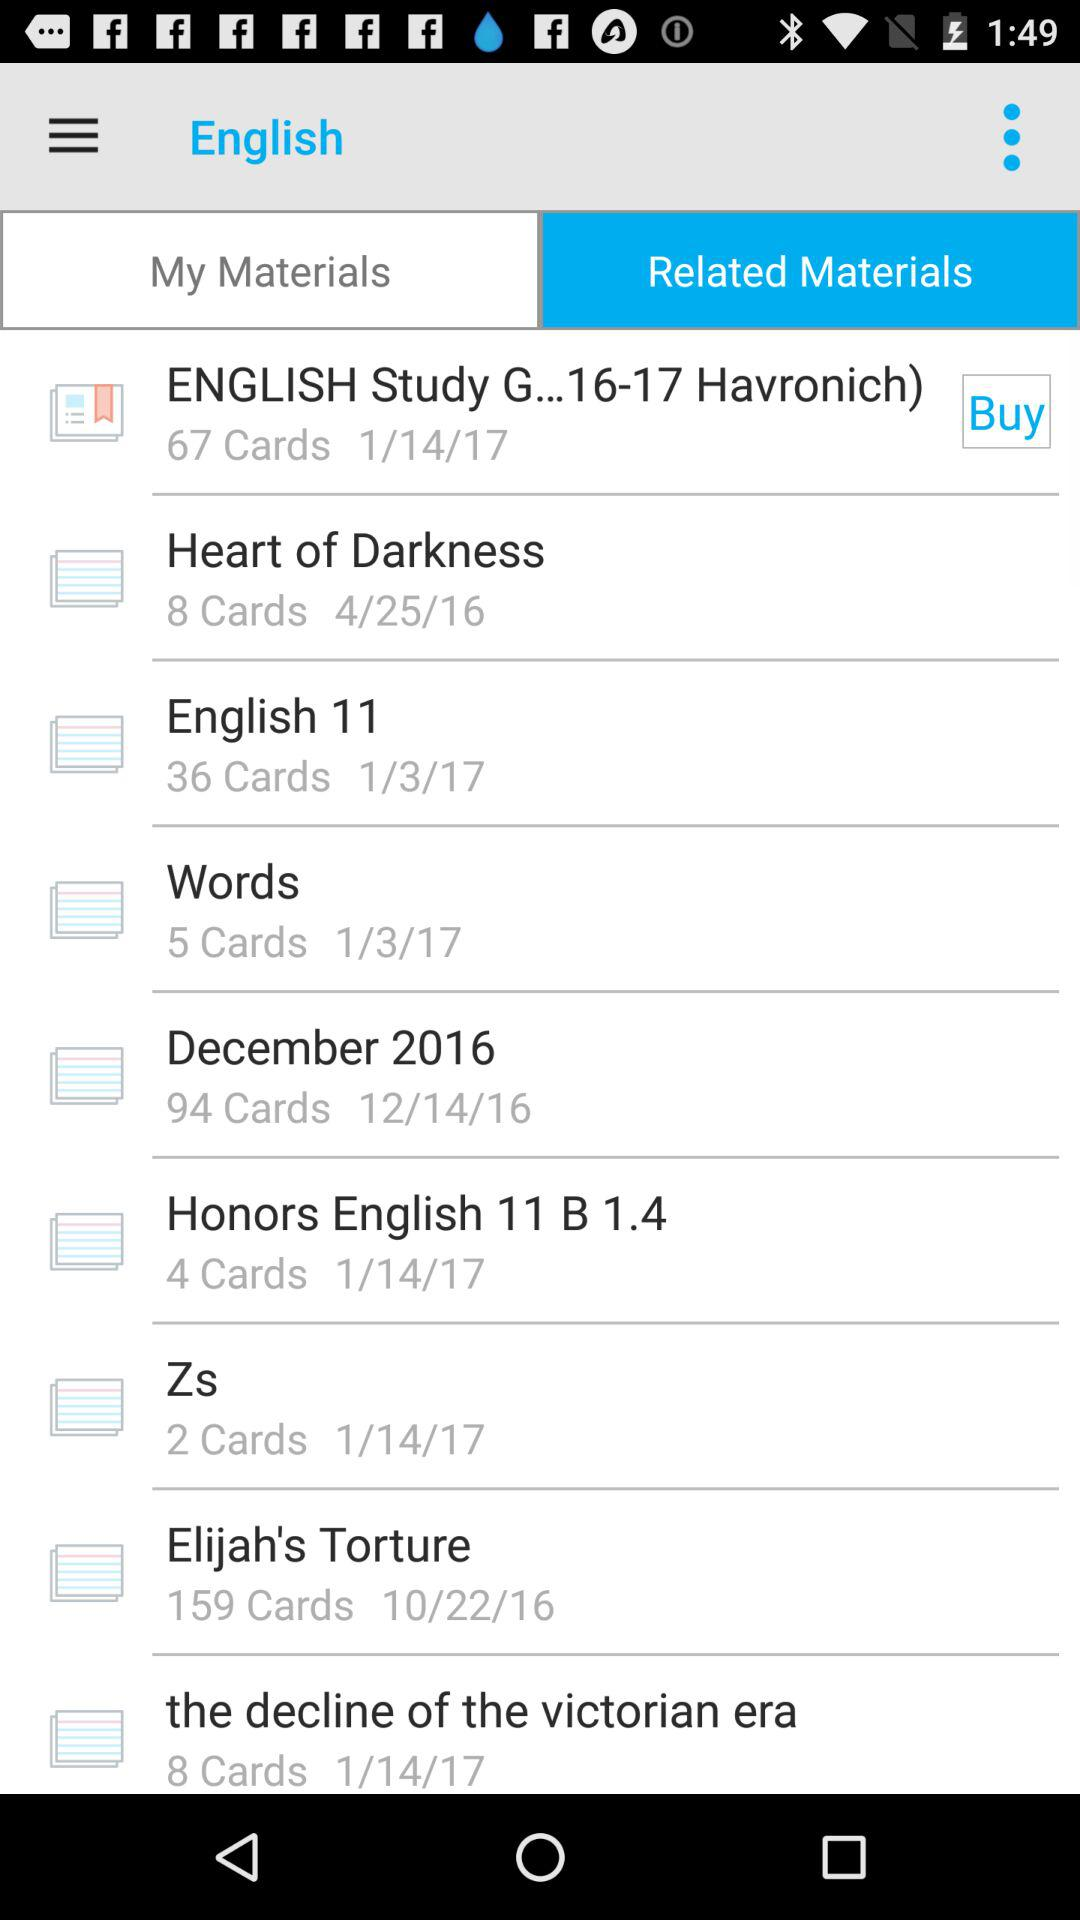How many cards are in the "English Study G...16-17 Havronich" material?
Answer the question using a single word or phrase. 67 